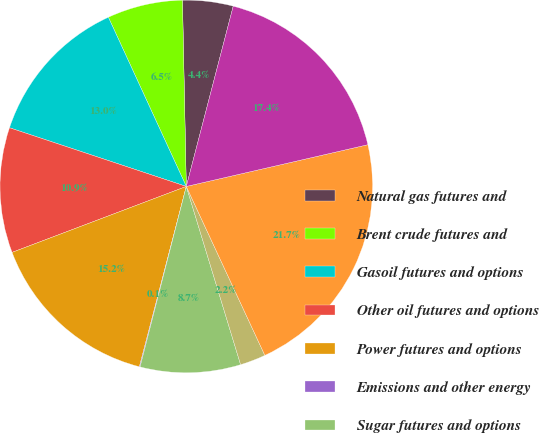<chart> <loc_0><loc_0><loc_500><loc_500><pie_chart><fcel>Natural gas futures and<fcel>Brent crude futures and<fcel>Gasoil futures and options<fcel>Other oil futures and options<fcel>Power futures and options<fcel>Emissions and other energy<fcel>Sugar futures and options<fcel>Other agricultural and metals<fcel>Other financial futures and<fcel>Total<nl><fcel>4.38%<fcel>6.54%<fcel>13.03%<fcel>10.86%<fcel>15.19%<fcel>0.06%<fcel>8.7%<fcel>2.22%<fcel>21.67%<fcel>17.35%<nl></chart> 